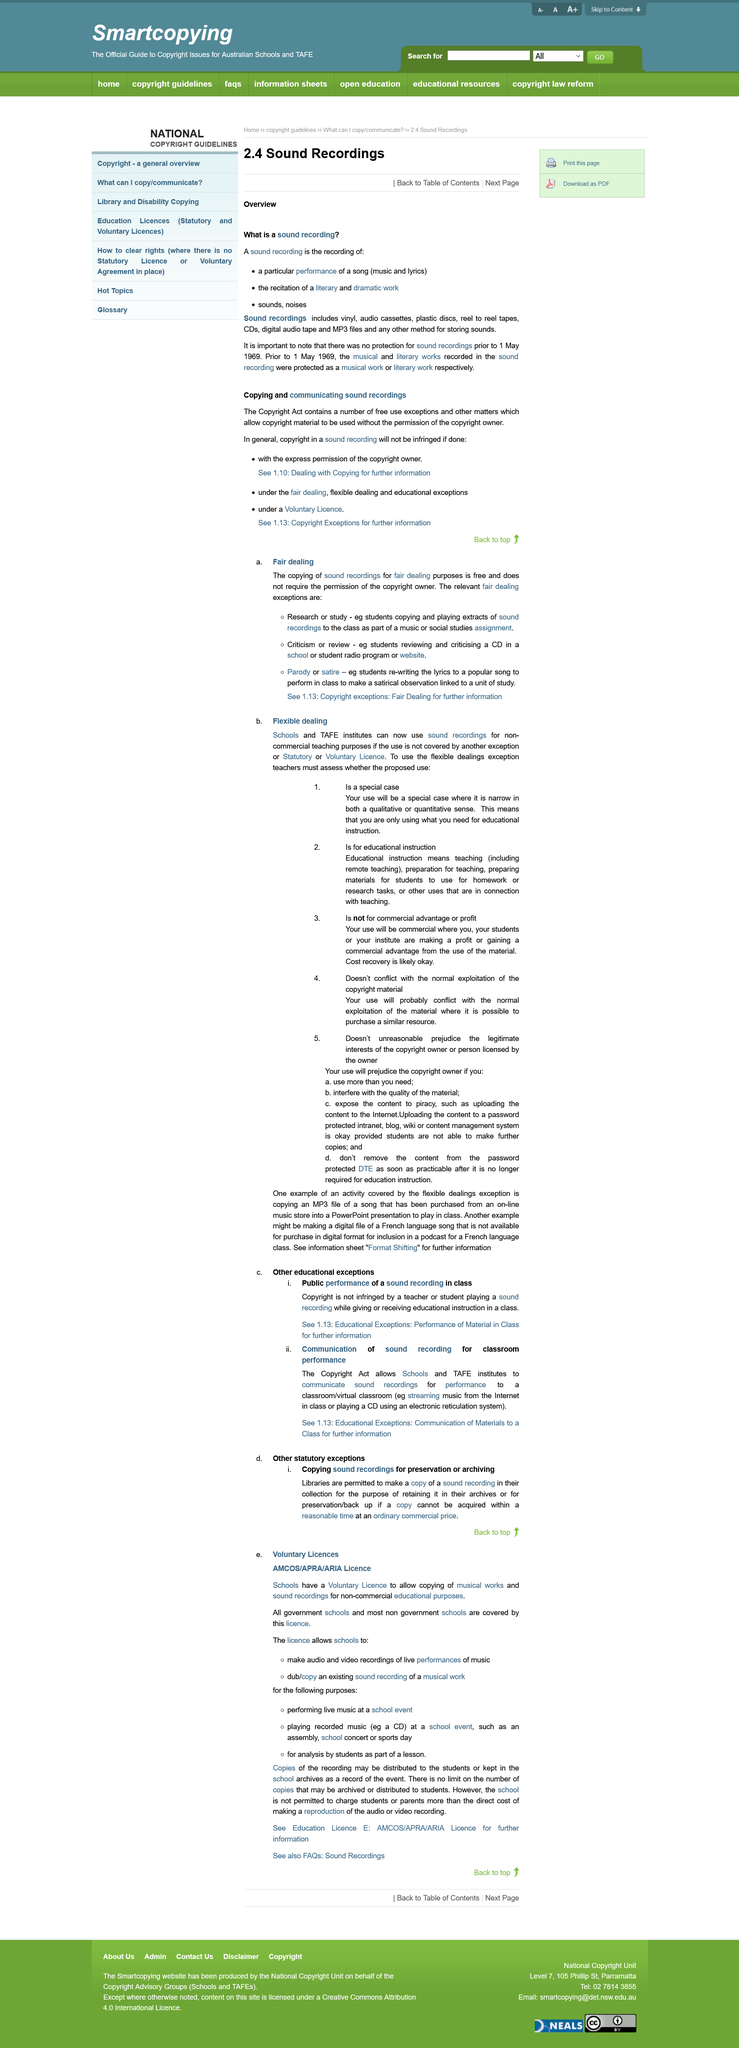Point out several critical features in this image. Schools are not authorized to use sound recordings for any purpose other than educational instruction. In 1969, the protection for sound recordings began. There are several mediums on which sound can be recorded, including vinyl records, audio cassettes, plastic discs, reel to reel tapes, CDs, digital audio tape, and MP3 files. There are three types of sound recordings, including: 1) a particular performance of a song, 2) the recitation of a literary and dramatic work, and 3) sounds or noises. TAFE institutes are permitted to use sound recordings for remote teaching purposes. 